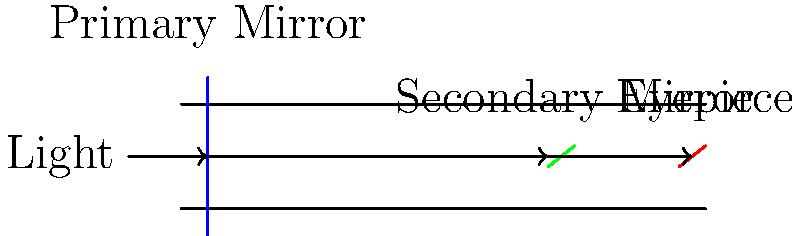In the cross-section diagram of a reflecting telescope shown above, what is the primary function of the secondary mirror in relation to the light path and image formation? To understand the function of the secondary mirror in a reflecting telescope, let's follow the light path step-by-step:

1. Light enters the telescope from the left side of the diagram.
2. The light travels until it reaches the primary mirror (blue) at the back of the telescope.
3. The primary mirror is concave and reflects the light back towards the front of the telescope.
4. Before reaching the focal point, the light encounters the secondary mirror (green).
5. The secondary mirror's primary function is to redirect the light:
   a) It reflects the light at a 90-degree angle.
   b) This redirection sends the light through a hole in the primary mirror.
   c) The light then reaches the eyepiece (red) at the back of the telescope.

6. By redirecting the light, the secondary mirror serves several important purposes:
   a) It allows for a more compact telescope design.
   b) It brings the focal point to a convenient viewing position for the observer.
   c) It helps to magnify the image further before it reaches the eyepiece.

7. In some designs, the secondary mirror may also be slightly convex to correct for aberrations in the primary mirror, improving image quality.

This setup, with a large primary mirror and a smaller secondary mirror, is known as a Newtonian reflector design, named after Sir Isaac Newton who invented it.
Answer: Redirect light to the eyepiece 